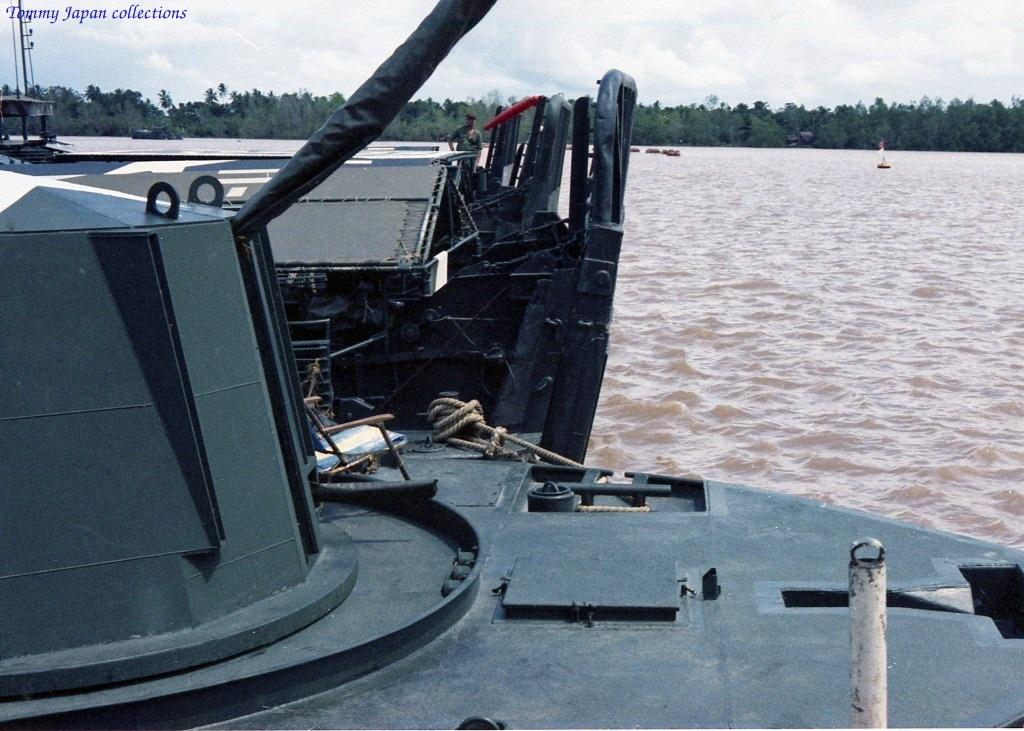What is the main subject of the image? There is a ship in the image. Can you describe the person on the ship? A man is standing on the ship. What is one feature of the ship? There is a pole on the ship. What else can be seen on the ship? There are objects on the ship. What else is present in the water near the ship? There is a boat on the water. What can be seen in the background of the image? Trees and the sky with clouds are visible in the background. How many cakes are being sold on the ship in the image? There is no mention of cakes or any selling activity in the image. The image only shows a ship with a man, a pole, and other objects on it, along with a boat in the water and trees and clouds in the background. 